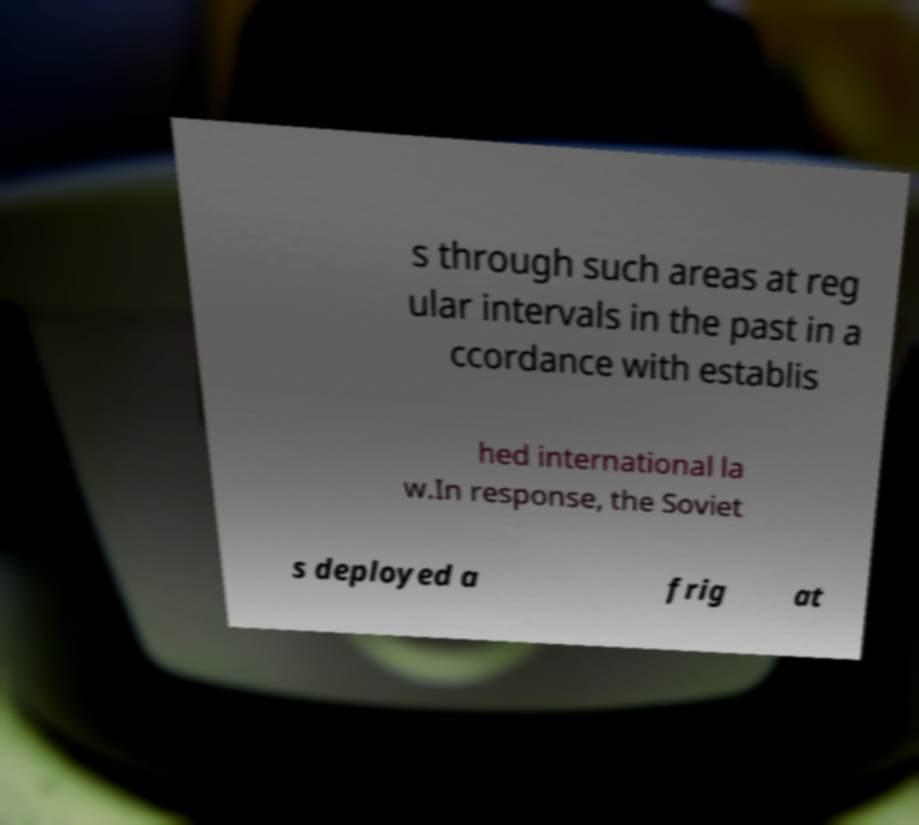I need the written content from this picture converted into text. Can you do that? s through such areas at reg ular intervals in the past in a ccordance with establis hed international la w.In response, the Soviet s deployed a frig at 